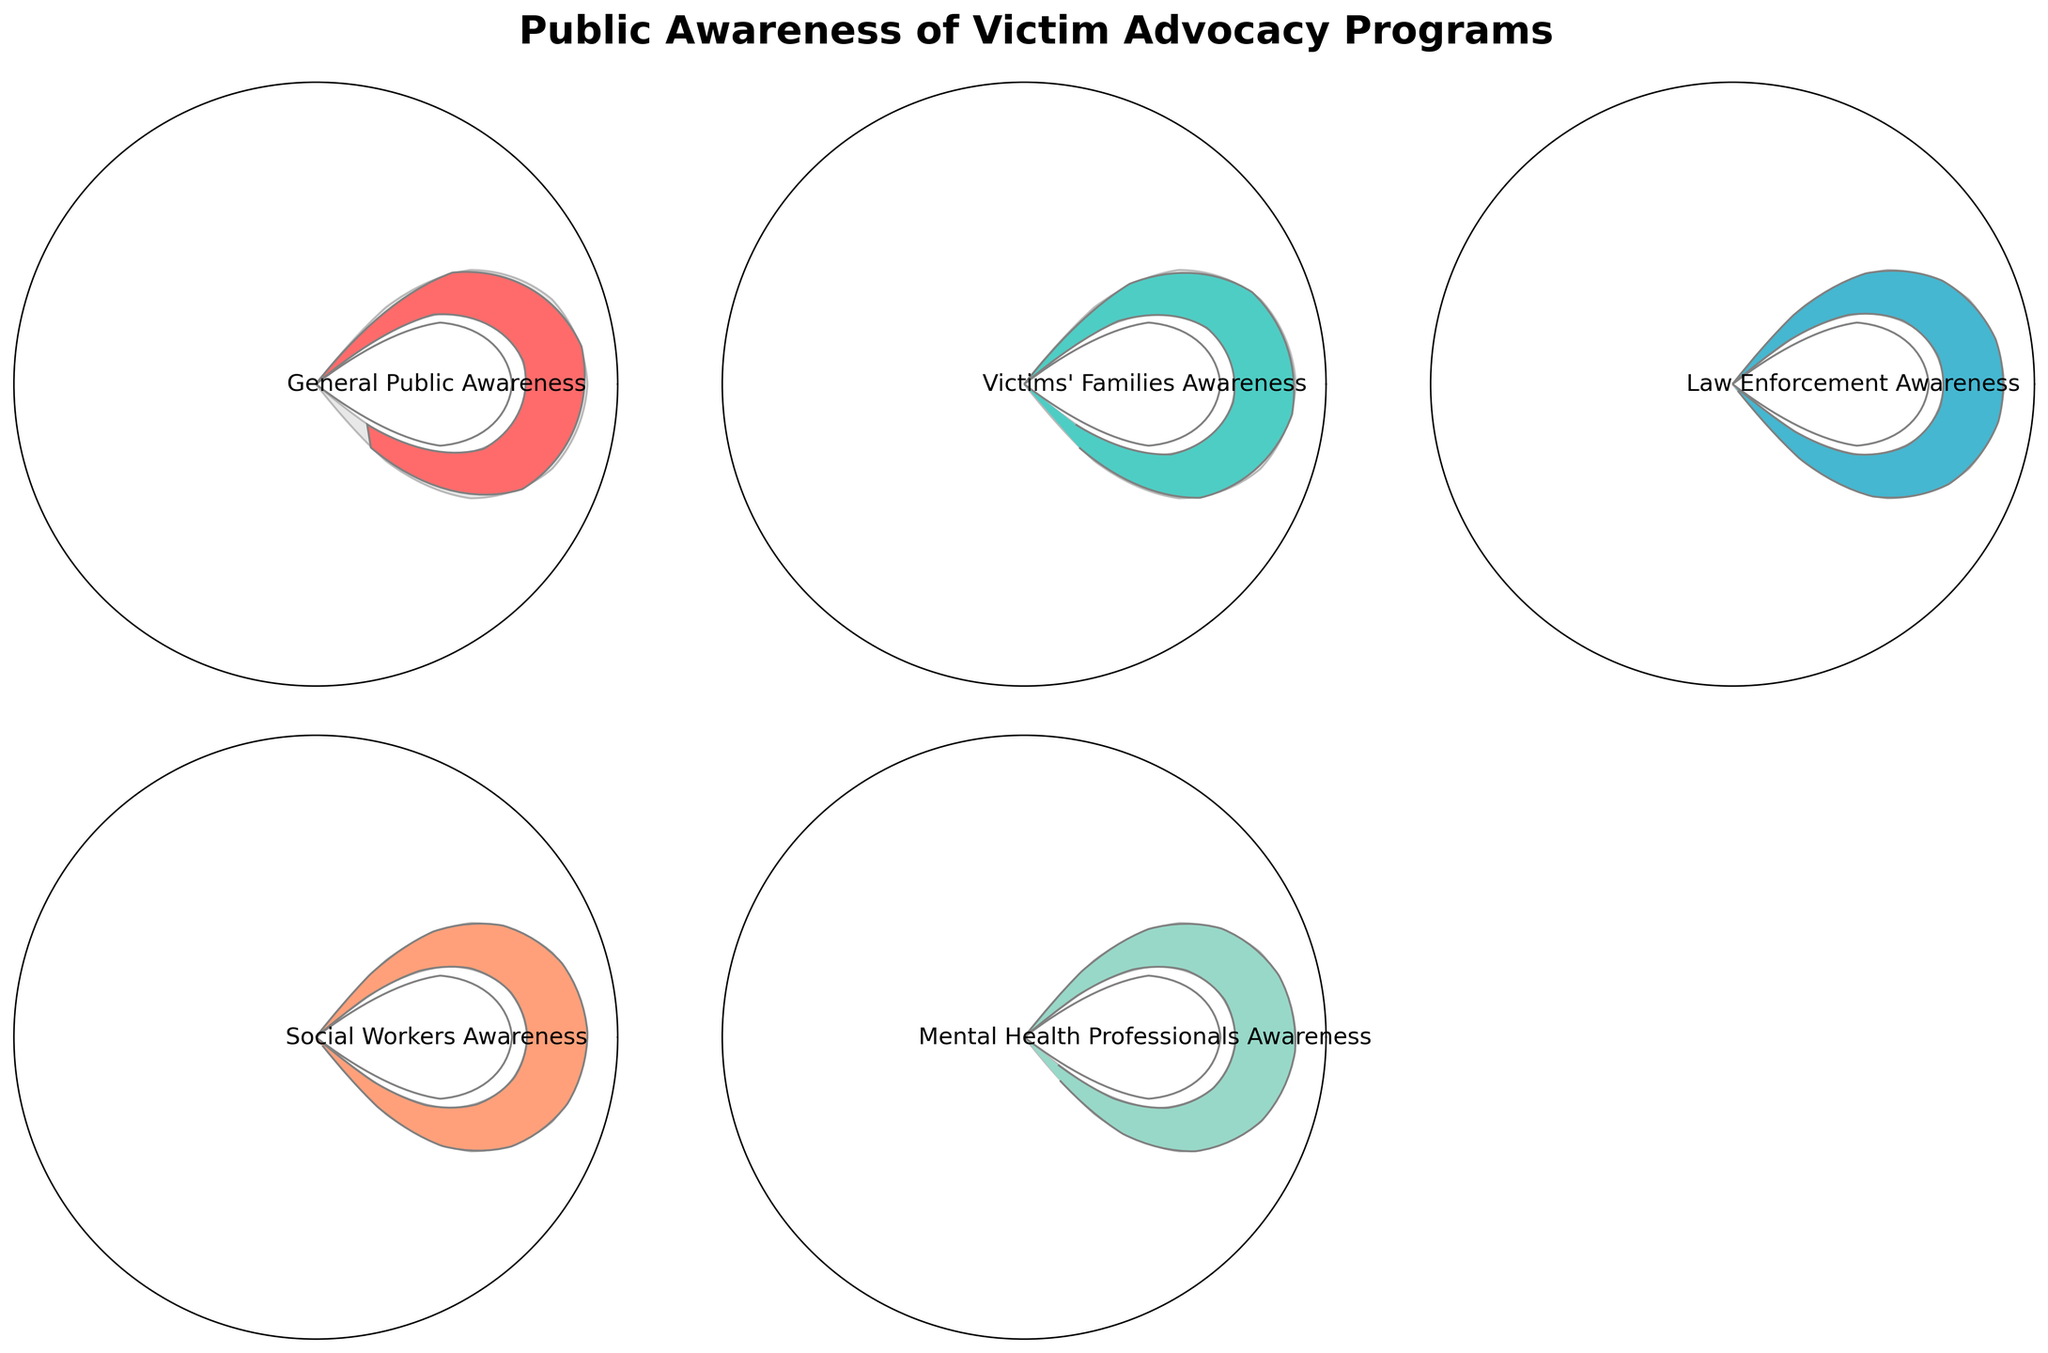How many different categories of awareness are depicted in the chart? By examining the figure, you can see that there are individual gauge charts representing different categories. Counting these, there are five categories shown.
Answer: Five What is the highest awareness percentage shown in the chart, and which group does it represent? By looking at the gauge charts, you can see the maximum values. The chart with the highest percentage is for Law Enforcement Awareness, which shows 88%.
Answer: 88%, Law Enforcement Awareness Which group has the lowest awareness percentage in the chart? Comparing the values shown in each gauge chart, the lowest percentage is 45% for General Public Awareness.
Answer: General Public Awareness How much higher is the awareness percentage among Mental Health Professionals compared to the General Public? Mental Health Professionals have an awareness percentage of 83%, and General Public Awareness is 45%. The difference is 83% - 45% = 38%.
Answer: 38% What is the average awareness percentage across all groups depicted? To find the average, sum up the percentages of all groups and then divide by the number of groups. The percentages are 45, 72, 88, 79, and 83. The sum is 45 + 72 + 88 + 79 + 83 = 367. There are 5 groups, so the average is 367 / 5 = 73.4%.
Answer: 73.4% Which groups have an awareness percentage higher than 75%? By examining each gauge chart, the groups with awareness percentages higher than 75% are Victims' Families Awareness (72% not qualifying), Law Enforcement Awareness (88%), Social Workers Awareness (79%), and Mental Health Professionals Awareness (83%).
Answer: Law Enforcement Awareness, Social Workers Awareness, Mental Health Professionals Awareness What is the difference in awareness percentage between Social Workers and Victims' Families? Social Workers Awareness is at 79%, and Victims' Families Awareness is at 72%. The difference is 79% - 72% = 7%.
Answer: 7% Calculate the range of awareness percentages depicted in the chart. The range is determined by subtracting the lowest value from the highest value. The highest awareness percentage is 88% (Law Enforcement Awareness), and the lowest is 45% (General Public Awareness). Therefore, the range is 88% - 45% = 43%.
Answer: 43% What is the median awareness percentage of the groups represented? To find the median, first, list the values in ascending order: 45%, 72%, 79%, 83%, 88%. The median is the middle value in this ordered list, which is 79%.
Answer: 79% If the General Public Awareness increased by 10 percentage points, would it still be the lowest among the groups? Increasing the General Public Awareness by 10 percentage points would make it 55%. The lowest other value is 72%. Therefore, it would still be the lowest.
Answer: Yes 